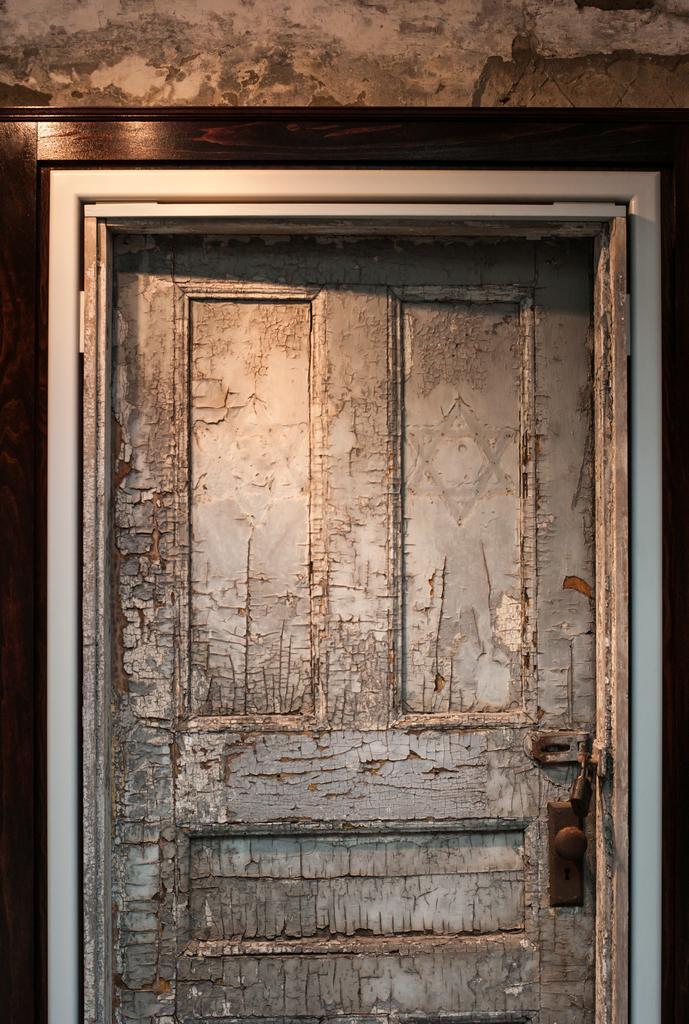What is located in the center of the image? There is a door in the center of the image. What else can be seen in the image? There is a wall in the image. Can you see any airplanes flying in the image? There are no airplanes visible in the image. Is there a goat present in the image? There is no goat present in the image. How many dogs can be seen in the image? There are no dogs present in the image. 